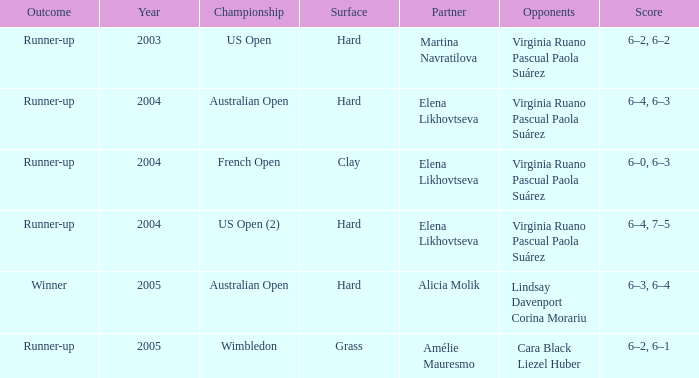For the us open (2) championship, what is the playing surface? Hard. 